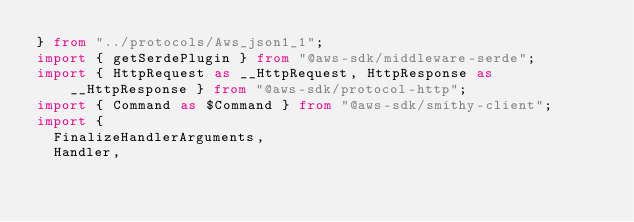Convert code to text. <code><loc_0><loc_0><loc_500><loc_500><_TypeScript_>} from "../protocols/Aws_json1_1";
import { getSerdePlugin } from "@aws-sdk/middleware-serde";
import { HttpRequest as __HttpRequest, HttpResponse as __HttpResponse } from "@aws-sdk/protocol-http";
import { Command as $Command } from "@aws-sdk/smithy-client";
import {
  FinalizeHandlerArguments,
  Handler,</code> 